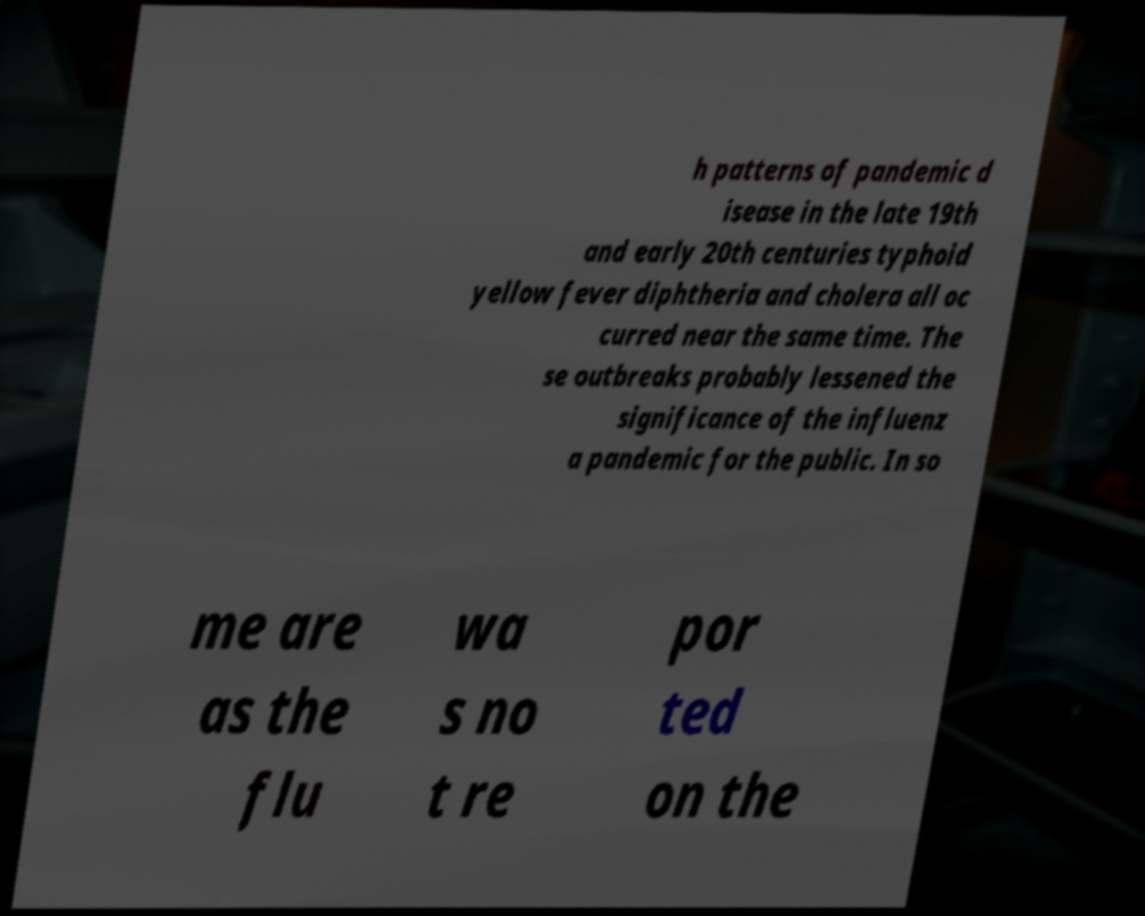There's text embedded in this image that I need extracted. Can you transcribe it verbatim? h patterns of pandemic d isease in the late 19th and early 20th centuries typhoid yellow fever diphtheria and cholera all oc curred near the same time. The se outbreaks probably lessened the significance of the influenz a pandemic for the public. In so me are as the flu wa s no t re por ted on the 